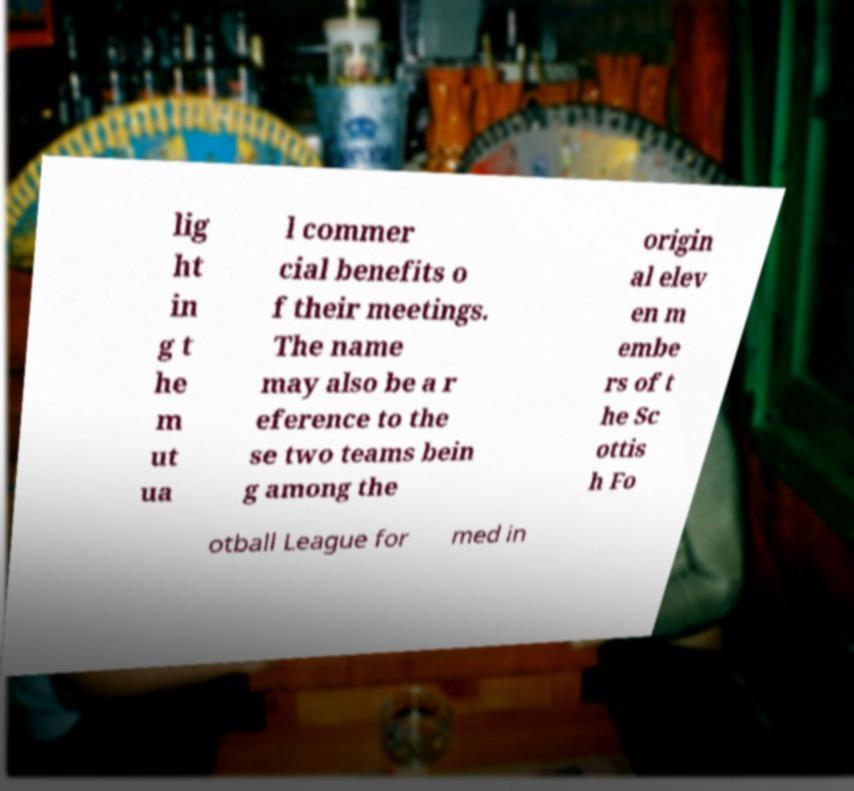For documentation purposes, I need the text within this image transcribed. Could you provide that? lig ht in g t he m ut ua l commer cial benefits o f their meetings. The name may also be a r eference to the se two teams bein g among the origin al elev en m embe rs of t he Sc ottis h Fo otball League for med in 